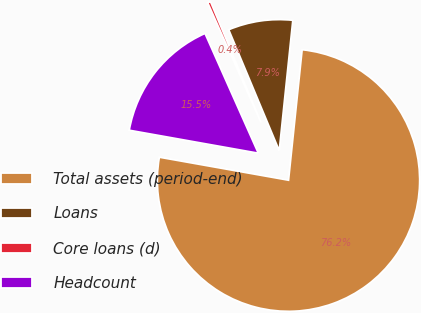Convert chart to OTSL. <chart><loc_0><loc_0><loc_500><loc_500><pie_chart><fcel>Total assets (period-end)<fcel>Loans<fcel>Core loans (d)<fcel>Headcount<nl><fcel>76.15%<fcel>7.95%<fcel>0.37%<fcel>15.53%<nl></chart> 